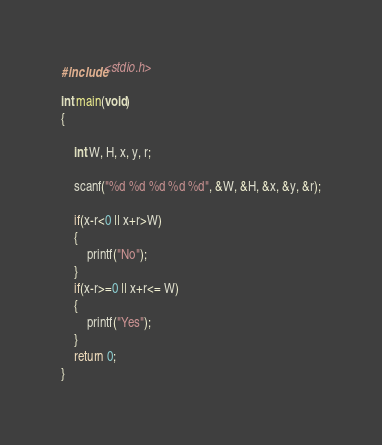<code> <loc_0><loc_0><loc_500><loc_500><_C_>#include<stdio.h>

int main(void)
{

	int W, H, x, y, r;

	scanf("%d %d %d %d %d", &W, &H, &x, &y, &r);

	if(x-r<0 || x+r>W)
	{
		printf("No");
	}
	if(x-r>=0 || x+r<= W)
	{
		printf("Yes");
	}
	return 0;
}
</code> 